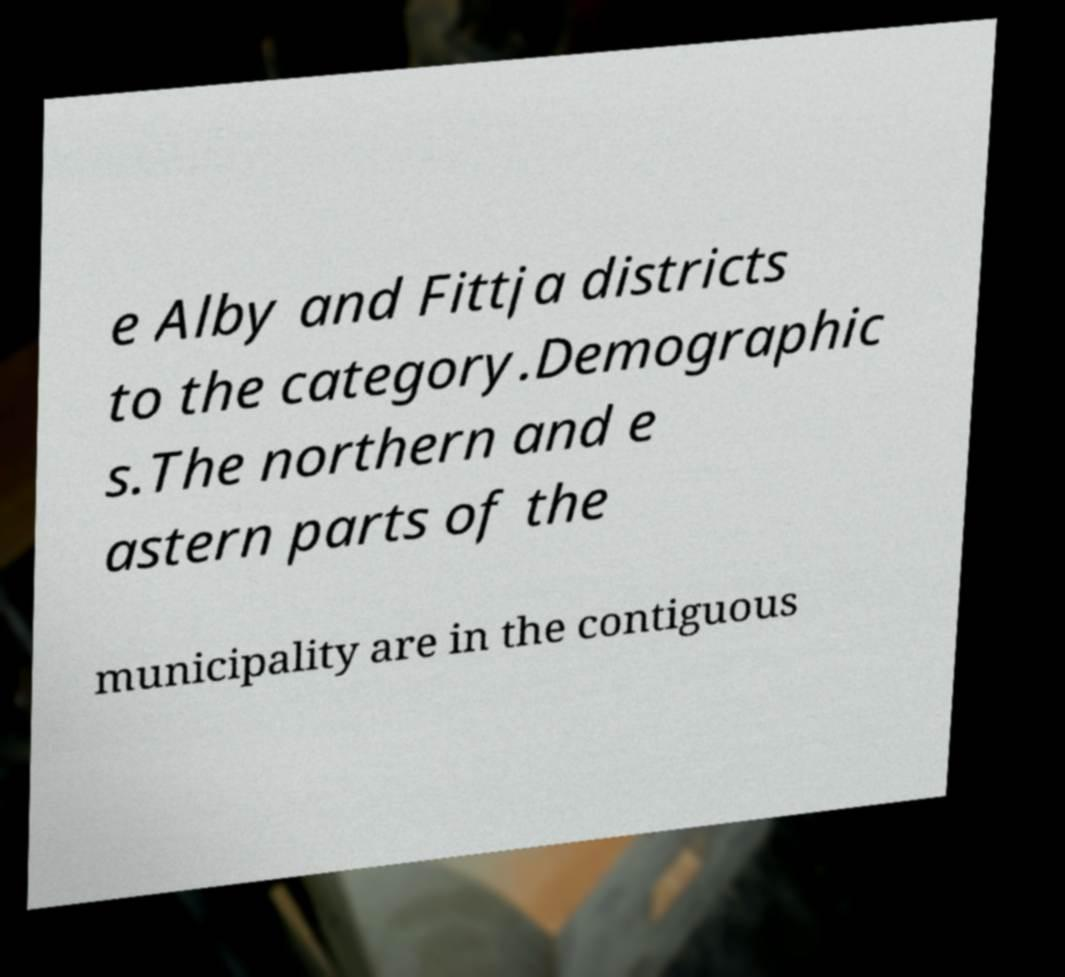Can you read and provide the text displayed in the image?This photo seems to have some interesting text. Can you extract and type it out for me? e Alby and Fittja districts to the category.Demographic s.The northern and e astern parts of the municipality are in the contiguous 